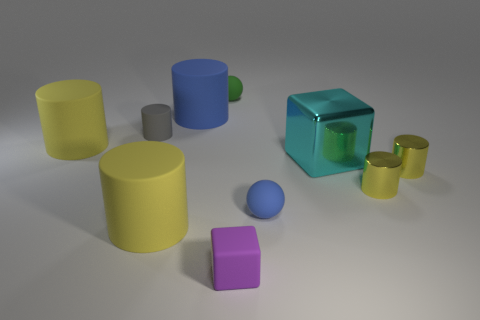Subtract all rubber cylinders. How many cylinders are left? 2 Subtract all purple blocks. How many blocks are left? 1 Subtract all cubes. How many objects are left? 8 Add 6 large cyan rubber cylinders. How many large cyan rubber cylinders exist? 6 Subtract 0 brown cubes. How many objects are left? 10 Subtract 1 blocks. How many blocks are left? 1 Subtract all purple blocks. Subtract all red cylinders. How many blocks are left? 1 Subtract all purple cylinders. How many yellow blocks are left? 0 Subtract all green shiny cubes. Subtract all small yellow metallic objects. How many objects are left? 8 Add 4 tiny metallic cylinders. How many tiny metallic cylinders are left? 6 